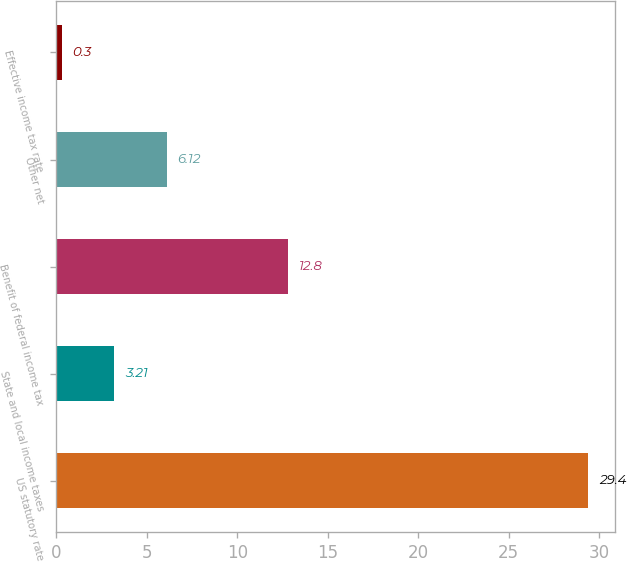Convert chart. <chart><loc_0><loc_0><loc_500><loc_500><bar_chart><fcel>US statutory rate<fcel>State and local income taxes<fcel>Benefit of federal income tax<fcel>Other net<fcel>Effective income tax rate<nl><fcel>29.4<fcel>3.21<fcel>12.8<fcel>6.12<fcel>0.3<nl></chart> 